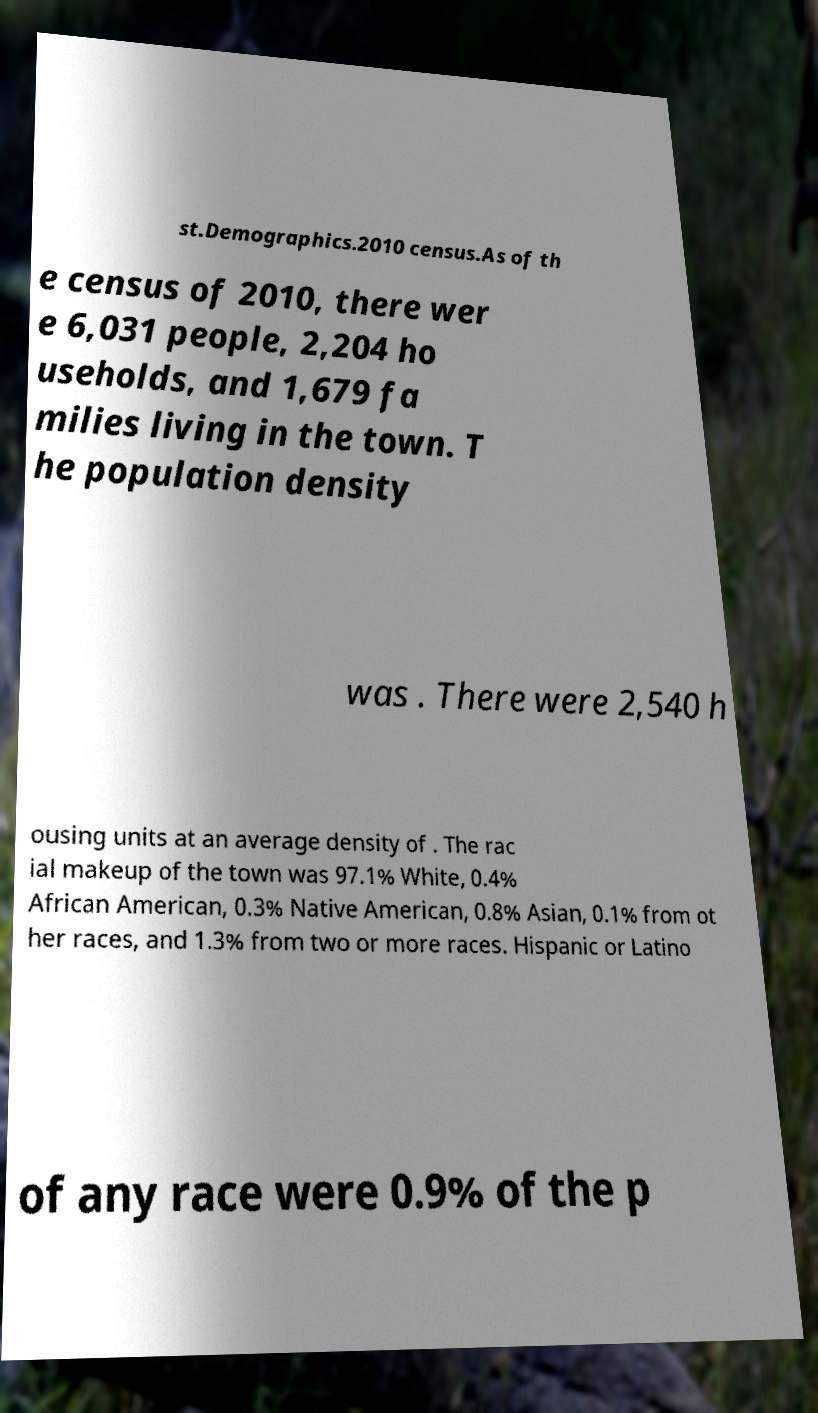Can you accurately transcribe the text from the provided image for me? st.Demographics.2010 census.As of th e census of 2010, there wer e 6,031 people, 2,204 ho useholds, and 1,679 fa milies living in the town. T he population density was . There were 2,540 h ousing units at an average density of . The rac ial makeup of the town was 97.1% White, 0.4% African American, 0.3% Native American, 0.8% Asian, 0.1% from ot her races, and 1.3% from two or more races. Hispanic or Latino of any race were 0.9% of the p 